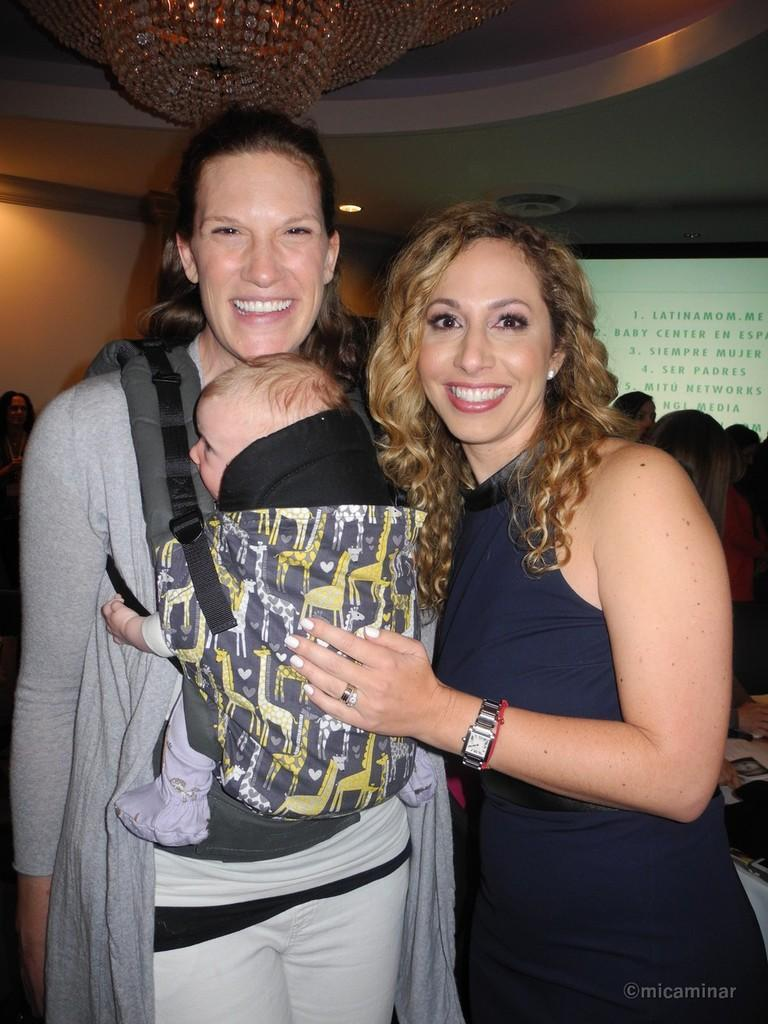How many women are in the image? There are two women standing in the center of the image. What can be seen in the background of the image? There is a screen and a wall in the background of the image. Are there any other people visible in the image? Yes, there are people in the background of the image. What is visible above the women in the image? There is a ceiling visible in the image, and a chandelier is hanging from it. What type of surprise can be seen on the tooth of one of the women in the image? There is no tooth visible in the image, and therefore no surprise can be seen on it. 